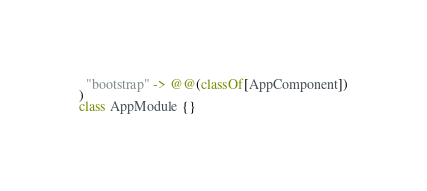Convert code to text. <code><loc_0><loc_0><loc_500><loc_500><_Scala_>  "bootstrap" -> @@(classOf[AppComponent])
)
class AppModule {}
</code> 